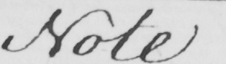Can you read and transcribe this handwriting? Note 